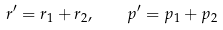Convert formula to latex. <formula><loc_0><loc_0><loc_500><loc_500>r ^ { \prime } = r _ { 1 } + r _ { 2 } , \quad p ^ { \prime } = p _ { 1 } + p _ { 2 }</formula> 